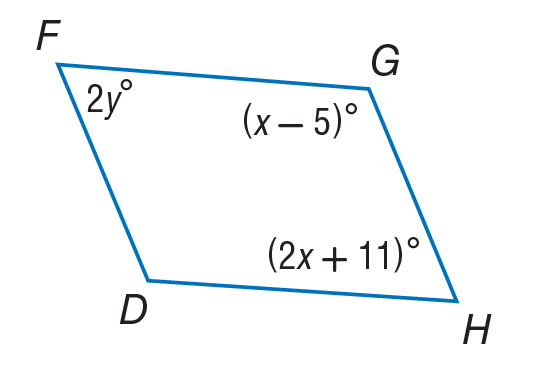Question: Use parallelogram to find y.
Choices:
A. 26.5
B. 53
C. 63.5
D. 127
Answer with the letter. Answer: C 